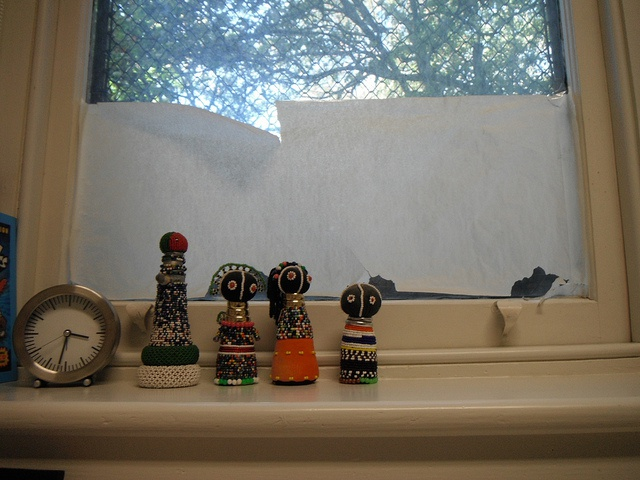Describe the objects in this image and their specific colors. I can see a clock in maroon, gray, and black tones in this image. 